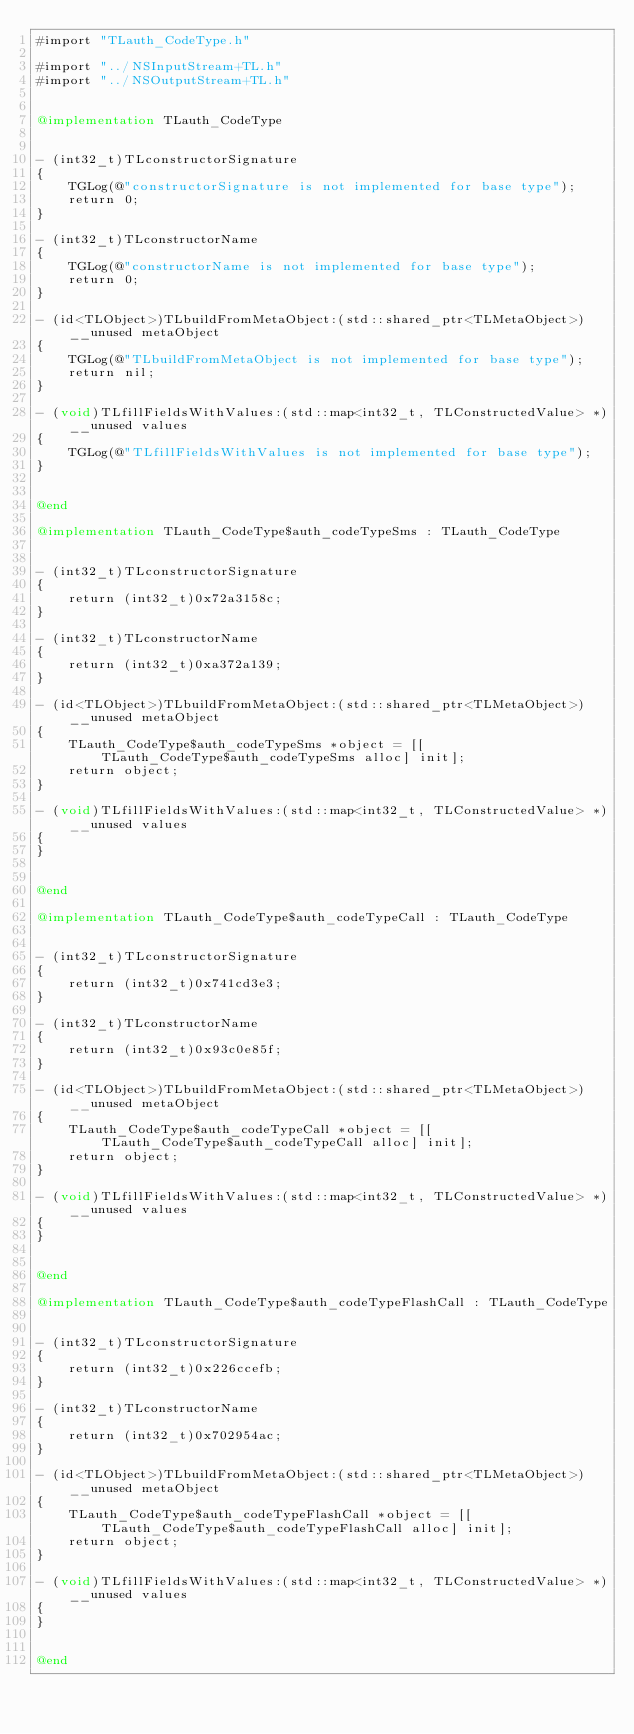Convert code to text. <code><loc_0><loc_0><loc_500><loc_500><_ObjectiveC_>#import "TLauth_CodeType.h"

#import "../NSInputStream+TL.h"
#import "../NSOutputStream+TL.h"


@implementation TLauth_CodeType


- (int32_t)TLconstructorSignature
{
    TGLog(@"constructorSignature is not implemented for base type");
    return 0;
}

- (int32_t)TLconstructorName
{
    TGLog(@"constructorName is not implemented for base type");
    return 0;
}

- (id<TLObject>)TLbuildFromMetaObject:(std::shared_ptr<TLMetaObject>)__unused metaObject
{
    TGLog(@"TLbuildFromMetaObject is not implemented for base type");
    return nil;
}

- (void)TLfillFieldsWithValues:(std::map<int32_t, TLConstructedValue> *)__unused values
{
    TGLog(@"TLfillFieldsWithValues is not implemented for base type");
}


@end

@implementation TLauth_CodeType$auth_codeTypeSms : TLauth_CodeType


- (int32_t)TLconstructorSignature
{
    return (int32_t)0x72a3158c;
}

- (int32_t)TLconstructorName
{
    return (int32_t)0xa372a139;
}

- (id<TLObject>)TLbuildFromMetaObject:(std::shared_ptr<TLMetaObject>)__unused metaObject
{
    TLauth_CodeType$auth_codeTypeSms *object = [[TLauth_CodeType$auth_codeTypeSms alloc] init];
    return object;
}

- (void)TLfillFieldsWithValues:(std::map<int32_t, TLConstructedValue> *)__unused values
{
}


@end

@implementation TLauth_CodeType$auth_codeTypeCall : TLauth_CodeType


- (int32_t)TLconstructorSignature
{
    return (int32_t)0x741cd3e3;
}

- (int32_t)TLconstructorName
{
    return (int32_t)0x93c0e85f;
}

- (id<TLObject>)TLbuildFromMetaObject:(std::shared_ptr<TLMetaObject>)__unused metaObject
{
    TLauth_CodeType$auth_codeTypeCall *object = [[TLauth_CodeType$auth_codeTypeCall alloc] init];
    return object;
}

- (void)TLfillFieldsWithValues:(std::map<int32_t, TLConstructedValue> *)__unused values
{
}


@end

@implementation TLauth_CodeType$auth_codeTypeFlashCall : TLauth_CodeType


- (int32_t)TLconstructorSignature
{
    return (int32_t)0x226ccefb;
}

- (int32_t)TLconstructorName
{
    return (int32_t)0x702954ac;
}

- (id<TLObject>)TLbuildFromMetaObject:(std::shared_ptr<TLMetaObject>)__unused metaObject
{
    TLauth_CodeType$auth_codeTypeFlashCall *object = [[TLauth_CodeType$auth_codeTypeFlashCall alloc] init];
    return object;
}

- (void)TLfillFieldsWithValues:(std::map<int32_t, TLConstructedValue> *)__unused values
{
}


@end

</code> 